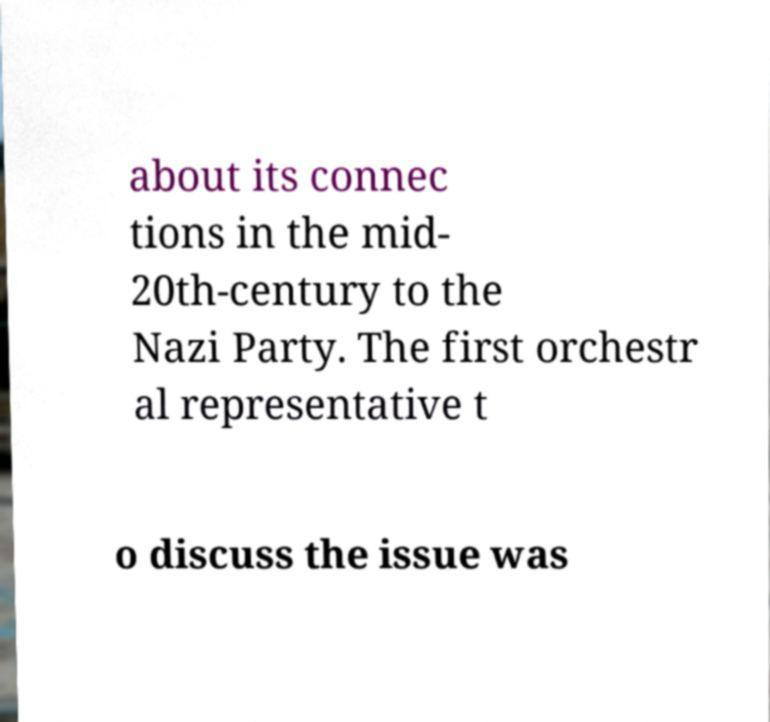What messages or text are displayed in this image? I need them in a readable, typed format. about its connec tions in the mid- 20th-century to the Nazi Party. The first orchestr al representative t o discuss the issue was 